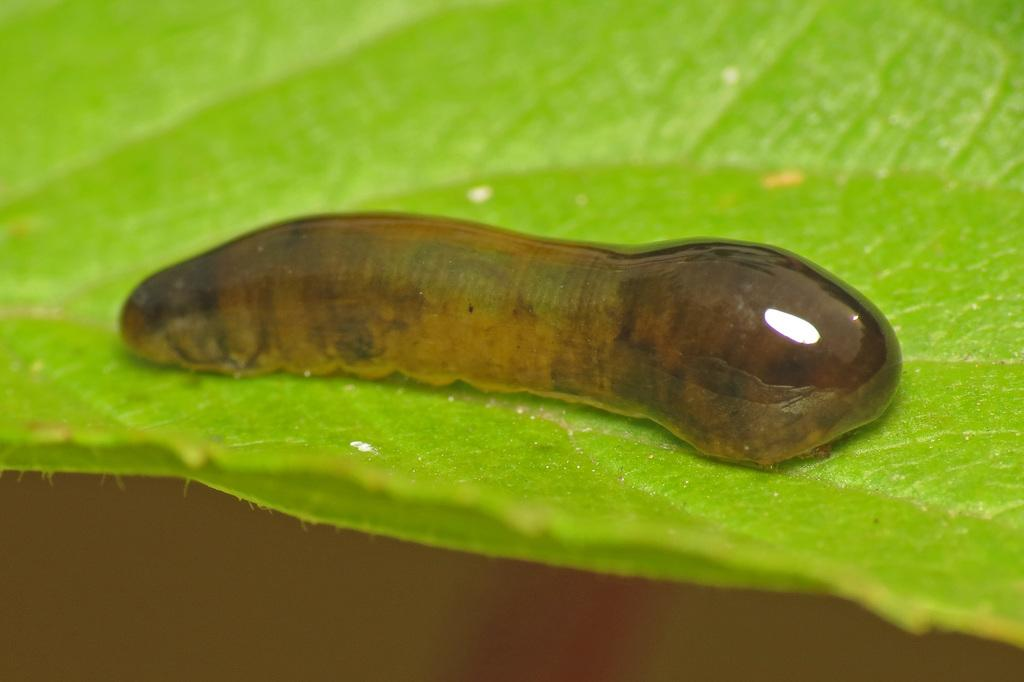What is the main subject of the image? The main subject of the image is a worm. Where is the worm located in the image? The worm is on a green leaf. What type of vegetable is the worm using to polish its shell in the image? There is no vegetable or shell present in the image, as it features a worm on a green leaf. 